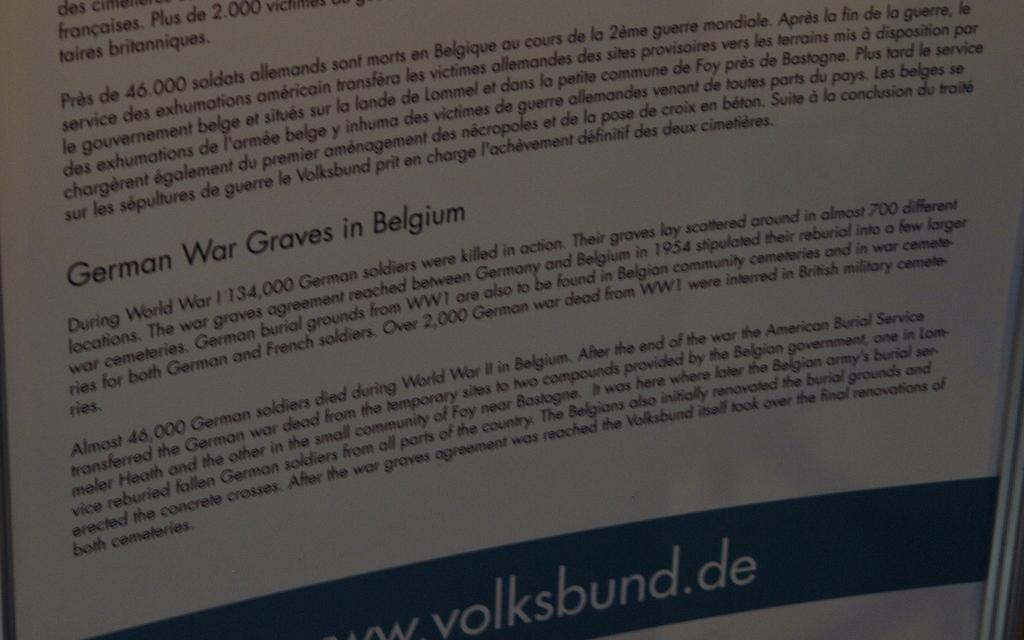<image>
Give a short and clear explanation of the subsequent image. Paper that explains information about belgium that had the German war 